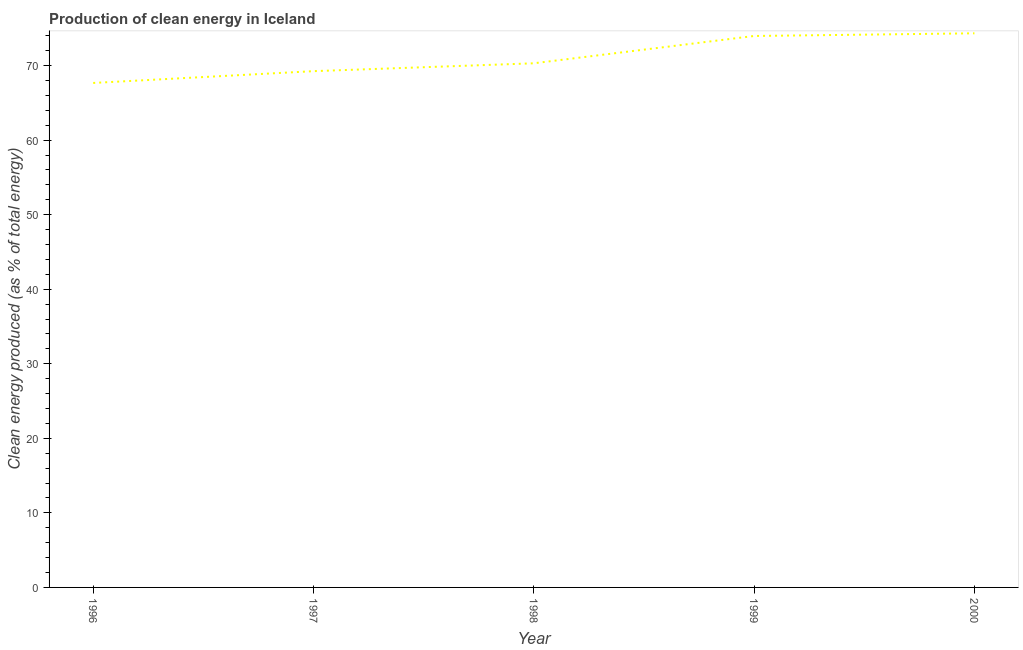What is the production of clean energy in 1996?
Your answer should be very brief. 67.67. Across all years, what is the maximum production of clean energy?
Provide a succinct answer. 74.33. Across all years, what is the minimum production of clean energy?
Offer a very short reply. 67.67. In which year was the production of clean energy maximum?
Your answer should be very brief. 2000. In which year was the production of clean energy minimum?
Ensure brevity in your answer.  1996. What is the sum of the production of clean energy?
Offer a terse response. 355.55. What is the difference between the production of clean energy in 1999 and 2000?
Offer a very short reply. -0.36. What is the average production of clean energy per year?
Give a very brief answer. 71.11. What is the median production of clean energy?
Your answer should be compact. 70.31. In how many years, is the production of clean energy greater than 54 %?
Provide a short and direct response. 5. Do a majority of the years between 1998 and 1999 (inclusive) have production of clean energy greater than 26 %?
Your answer should be very brief. Yes. What is the ratio of the production of clean energy in 1996 to that in 2000?
Your response must be concise. 0.91. Is the difference between the production of clean energy in 1999 and 2000 greater than the difference between any two years?
Offer a terse response. No. What is the difference between the highest and the second highest production of clean energy?
Keep it short and to the point. 0.36. Is the sum of the production of clean energy in 1999 and 2000 greater than the maximum production of clean energy across all years?
Ensure brevity in your answer.  Yes. What is the difference between the highest and the lowest production of clean energy?
Offer a very short reply. 6.66. Does the production of clean energy monotonically increase over the years?
Provide a short and direct response. Yes. How many years are there in the graph?
Provide a short and direct response. 5. Does the graph contain any zero values?
Keep it short and to the point. No. What is the title of the graph?
Make the answer very short. Production of clean energy in Iceland. What is the label or title of the Y-axis?
Your response must be concise. Clean energy produced (as % of total energy). What is the Clean energy produced (as % of total energy) in 1996?
Keep it short and to the point. 67.67. What is the Clean energy produced (as % of total energy) of 1997?
Provide a short and direct response. 69.26. What is the Clean energy produced (as % of total energy) in 1998?
Your answer should be compact. 70.31. What is the Clean energy produced (as % of total energy) of 1999?
Ensure brevity in your answer.  73.98. What is the Clean energy produced (as % of total energy) of 2000?
Make the answer very short. 74.33. What is the difference between the Clean energy produced (as % of total energy) in 1996 and 1997?
Your answer should be very brief. -1.58. What is the difference between the Clean energy produced (as % of total energy) in 1996 and 1998?
Make the answer very short. -2.64. What is the difference between the Clean energy produced (as % of total energy) in 1996 and 1999?
Offer a terse response. -6.3. What is the difference between the Clean energy produced (as % of total energy) in 1996 and 2000?
Keep it short and to the point. -6.66. What is the difference between the Clean energy produced (as % of total energy) in 1997 and 1998?
Your response must be concise. -1.05. What is the difference between the Clean energy produced (as % of total energy) in 1997 and 1999?
Provide a short and direct response. -4.72. What is the difference between the Clean energy produced (as % of total energy) in 1997 and 2000?
Offer a terse response. -5.08. What is the difference between the Clean energy produced (as % of total energy) in 1998 and 1999?
Offer a very short reply. -3.66. What is the difference between the Clean energy produced (as % of total energy) in 1998 and 2000?
Provide a succinct answer. -4.02. What is the difference between the Clean energy produced (as % of total energy) in 1999 and 2000?
Offer a terse response. -0.36. What is the ratio of the Clean energy produced (as % of total energy) in 1996 to that in 1999?
Make the answer very short. 0.92. What is the ratio of the Clean energy produced (as % of total energy) in 1996 to that in 2000?
Provide a succinct answer. 0.91. What is the ratio of the Clean energy produced (as % of total energy) in 1997 to that in 1999?
Your answer should be very brief. 0.94. What is the ratio of the Clean energy produced (as % of total energy) in 1997 to that in 2000?
Your answer should be compact. 0.93. What is the ratio of the Clean energy produced (as % of total energy) in 1998 to that in 2000?
Provide a succinct answer. 0.95. 